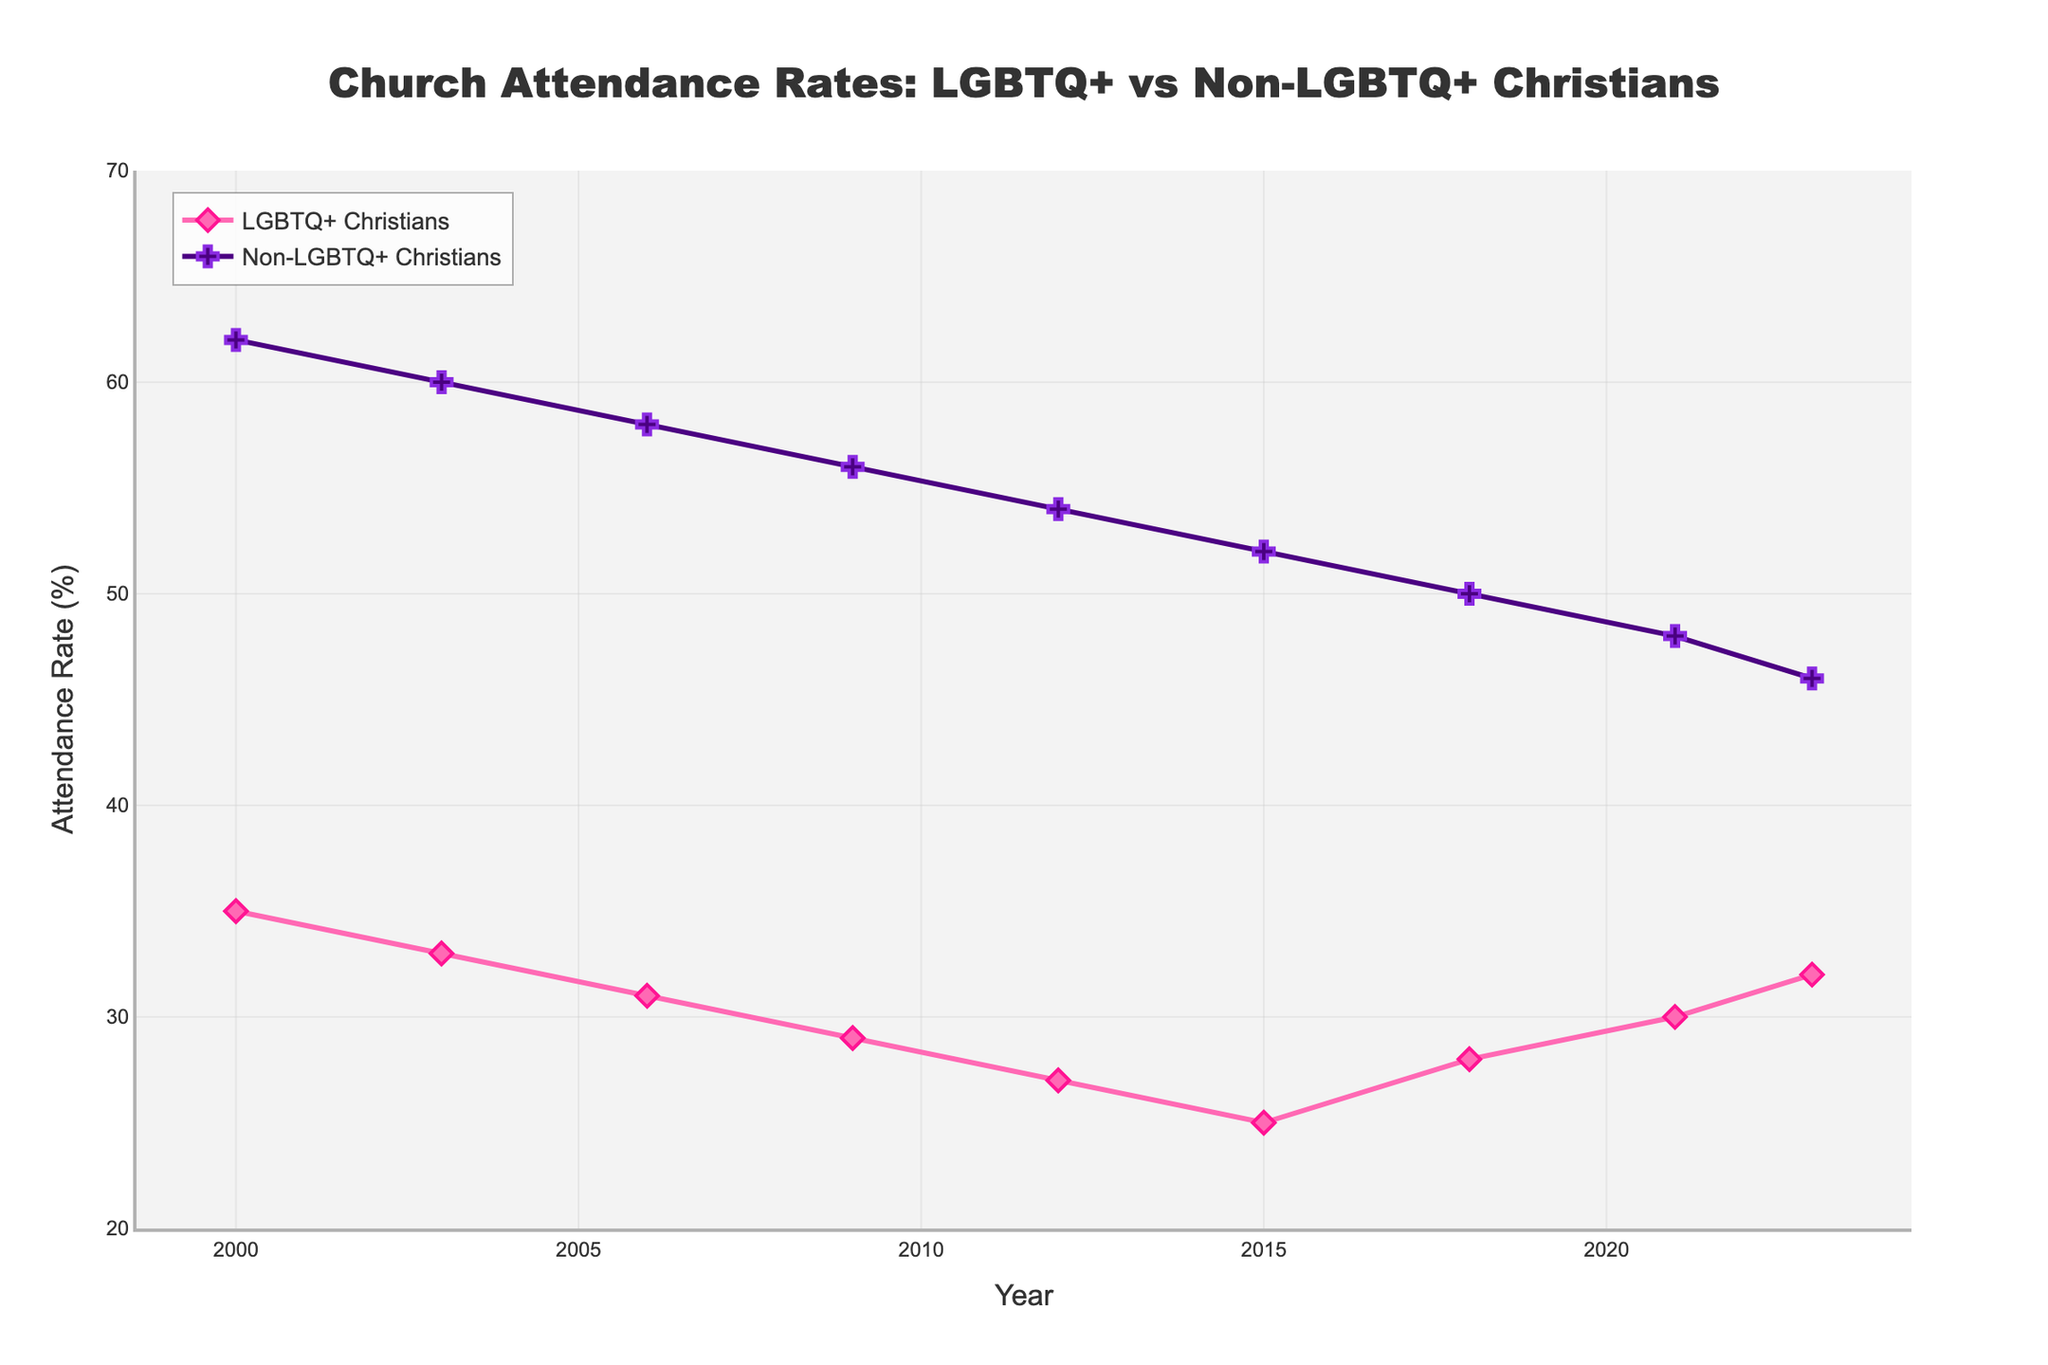What was the attendance rate for LGBTQ+ Christians in 2015? Refer to the year 2015 on the x-axis and see where the pink line (LGBTQ+ Christians) intersects it. The rate is shown as 25%.
Answer: 25% By how many percentage points did the church attendance rate for non-LGBTQ+ Christians decrease from 2000 to 2023? Find the value for non-LGBTQ+ Christians in 2000 (62%) and in 2023 (46%). The difference is calculated as 62% - 46% = 16%.
Answer: 16% In which year did LGBTQ+ Christians have their lowest attendance rate, and what was it? Observe the pink line (LGBTQ+ Christians) to find the lowest point, which occurs in 2015. The rate is 25%.
Answer: 2015, 25% Did non-LGBTQ+ Christians ever have a higher attendance rate than LGBTQ+ Christians throughout the period from 2000 to 2023? Compare the purple line (non-LGBTQ+ Christians) to the pink line for the entire period. The non-LGBTQ+ Christians' line is always higher.
Answer: Yes What was the difference in attendance rates between LGBTQ+ Christians and non-LGBTQ+ Christians in 2009? Find the values for both groups in 2009. LGBTQ+ Christians had a rate of 29%, and non-LGBTQ+ Christians had a rate of 56%. The difference is 56% - 29% = 27%.
Answer: 27% Between which two years did LGBTQ+ Christians see the highest increase in church attendance rates? Observe the pink line. The highest increase is from 2015 (25%) to 2018 (28%), which is an increase of 3 percentage points.
Answer: 2015 to 2018 Which year had the smallest difference in church attendance rates between LGBTQ+ Christians and non-LGBTQ+ Christians? Calculate the difference for each year between the rates for both groups. The smallest difference is in 2023, with 32% for LGBTQ+ Christians and 46% for non-LGBTQ+ Christians. The difference is 14 percentage points.
Answer: 2023 How did the attendance rate for non-LGBTQ+ Christians change from 2006 to 2012? Look at the values for 2006 (58%) and 2012 (54%). The rate decreased by 4 percentage points (58% - 54% = 4%).
Answer: Decreased by 4% What are the overall trends in church attendance rates for both LGBTQ+ Christians and non-LGBTQ+ Christians from 2000 to 2023? The pink line (LGBTQ+ Christians) generally shows a decreasing trend with a small rebound from 2018 to 2023. The purple line (non-LGBTQ+ Christians) consistently shows a steady decline.
Answer: Decreasing with rebound for LGBTQ+, steady decline for non-LGBTQ+ What is the overall average church attendance rate for LGBTQ+ Christians over the entire period? Sum the rates for LGBTQ+ Christians: 35 + 33 + 31 + 29 + 27 + 25 + 28 + 30 + 32 = 270. Divide by the number of years (9): 270 / 9 = 30.
Answer: 30% 